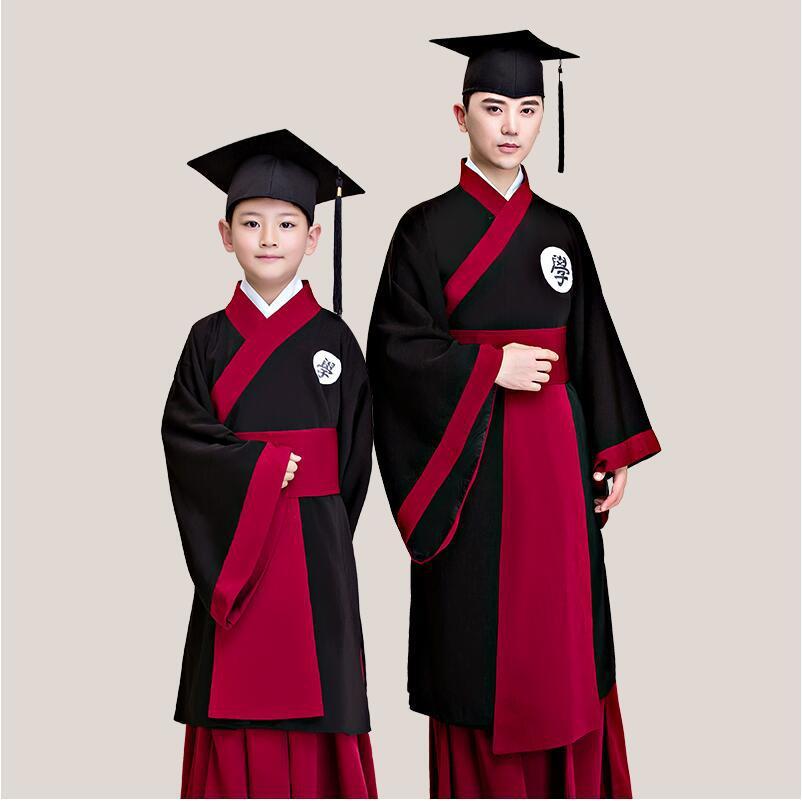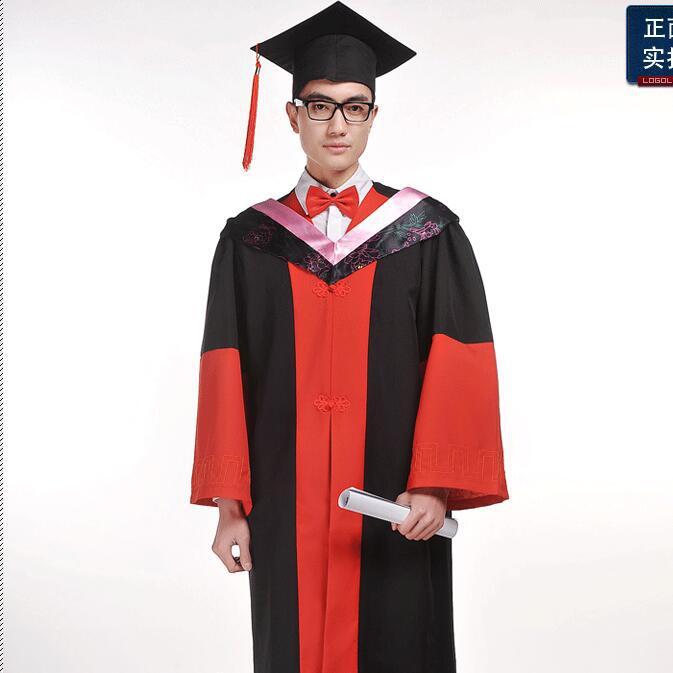The first image is the image on the left, the second image is the image on the right. Evaluate the accuracy of this statement regarding the images: "The people holding diplomas are not wearing glasses.". Is it true? Answer yes or no. No. The first image is the image on the left, the second image is the image on the right. Examine the images to the left and right. Is the description "a single little girl in a red cap and gown" accurate? Answer yes or no. No. 